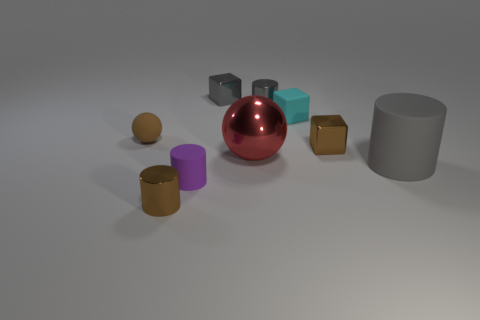There is a small rubber thing right of the red object; does it have the same color as the small matte thing that is to the left of the brown cylinder? No, the small rubber object to the right of the red sphere does not have the same color as the small matte object to the left of the brown cylinder; the rubber object is grey while the matte one is a distinct blue. 